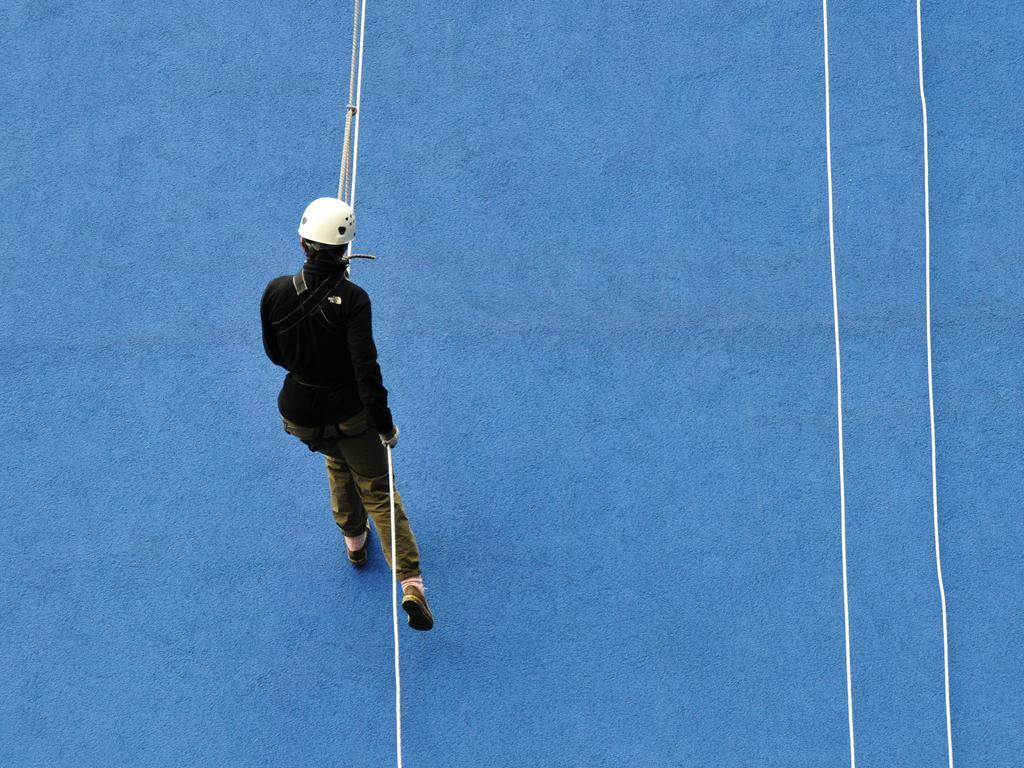Can you describe this image briefly? In this image there is a person climbing a wall by holding a rope, beside the person there are two other ropes hanging. 